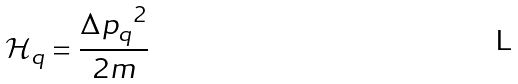Convert formula to latex. <formula><loc_0><loc_0><loc_500><loc_500>\mathcal { H } _ { q } = \frac { { { \Delta p } _ { q } } ^ { 2 } } { 2 m }</formula> 